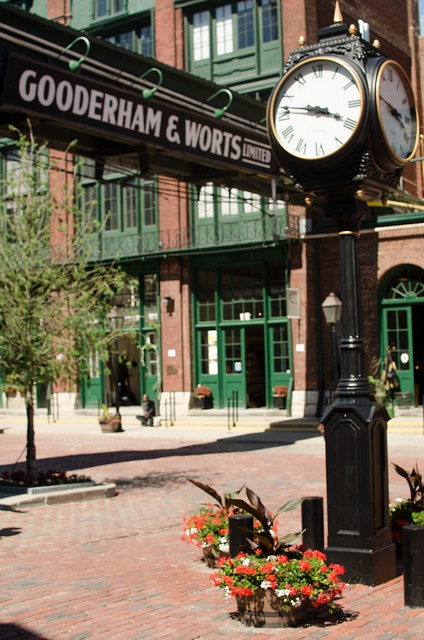Describe the objects in this image and their specific colors. I can see clock in teal, white, black, gray, and darkgray tones, potted plant in teal, black, olive, maroon, and tan tones, potted plant in teal, black, tan, and maroon tones, clock in teal, black, gray, and maroon tones, and potted plant in teal, black, tan, olive, and maroon tones in this image. 